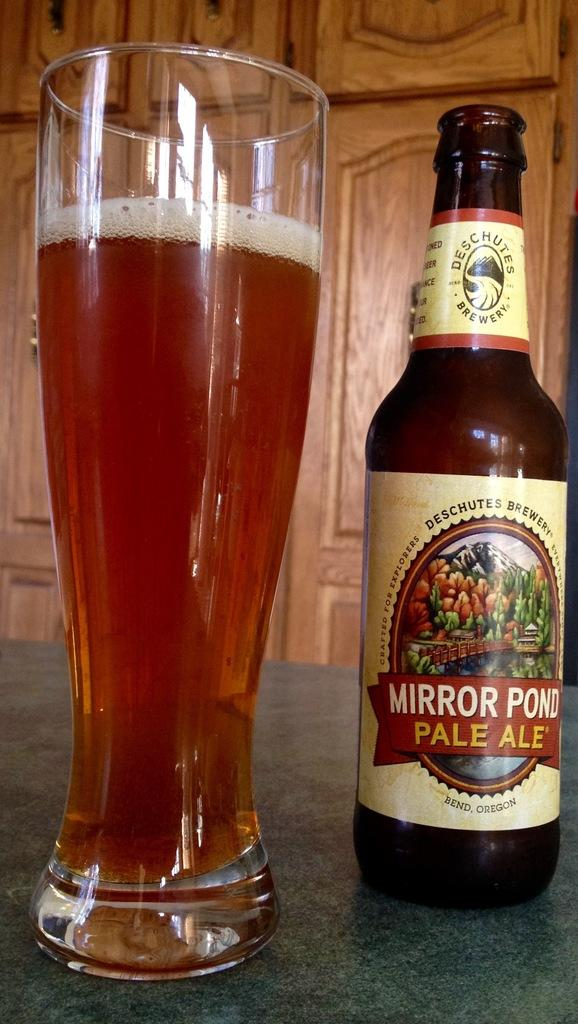<image>
Write a terse but informative summary of the picture. A bottle of Mirror Pond Pale Ale is next to a full glass. 